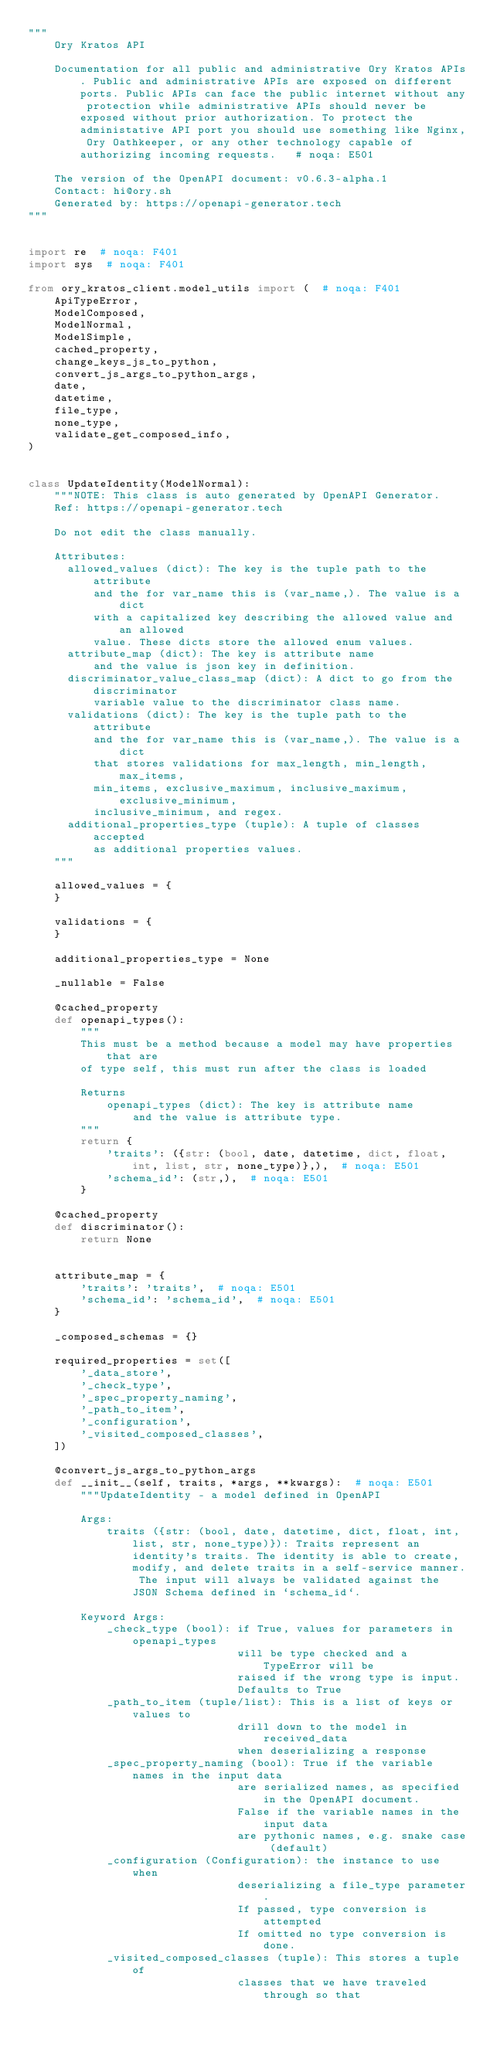Convert code to text. <code><loc_0><loc_0><loc_500><loc_500><_Python_>"""
    Ory Kratos API

    Documentation for all public and administrative Ory Kratos APIs. Public and administrative APIs are exposed on different ports. Public APIs can face the public internet without any protection while administrative APIs should never be exposed without prior authorization. To protect the administative API port you should use something like Nginx, Ory Oathkeeper, or any other technology capable of authorizing incoming requests.   # noqa: E501

    The version of the OpenAPI document: v0.6.3-alpha.1
    Contact: hi@ory.sh
    Generated by: https://openapi-generator.tech
"""


import re  # noqa: F401
import sys  # noqa: F401

from ory_kratos_client.model_utils import (  # noqa: F401
    ApiTypeError,
    ModelComposed,
    ModelNormal,
    ModelSimple,
    cached_property,
    change_keys_js_to_python,
    convert_js_args_to_python_args,
    date,
    datetime,
    file_type,
    none_type,
    validate_get_composed_info,
)


class UpdateIdentity(ModelNormal):
    """NOTE: This class is auto generated by OpenAPI Generator.
    Ref: https://openapi-generator.tech

    Do not edit the class manually.

    Attributes:
      allowed_values (dict): The key is the tuple path to the attribute
          and the for var_name this is (var_name,). The value is a dict
          with a capitalized key describing the allowed value and an allowed
          value. These dicts store the allowed enum values.
      attribute_map (dict): The key is attribute name
          and the value is json key in definition.
      discriminator_value_class_map (dict): A dict to go from the discriminator
          variable value to the discriminator class name.
      validations (dict): The key is the tuple path to the attribute
          and the for var_name this is (var_name,). The value is a dict
          that stores validations for max_length, min_length, max_items,
          min_items, exclusive_maximum, inclusive_maximum, exclusive_minimum,
          inclusive_minimum, and regex.
      additional_properties_type (tuple): A tuple of classes accepted
          as additional properties values.
    """

    allowed_values = {
    }

    validations = {
    }

    additional_properties_type = None

    _nullable = False

    @cached_property
    def openapi_types():
        """
        This must be a method because a model may have properties that are
        of type self, this must run after the class is loaded

        Returns
            openapi_types (dict): The key is attribute name
                and the value is attribute type.
        """
        return {
            'traits': ({str: (bool, date, datetime, dict, float, int, list, str, none_type)},),  # noqa: E501
            'schema_id': (str,),  # noqa: E501
        }

    @cached_property
    def discriminator():
        return None


    attribute_map = {
        'traits': 'traits',  # noqa: E501
        'schema_id': 'schema_id',  # noqa: E501
    }

    _composed_schemas = {}

    required_properties = set([
        '_data_store',
        '_check_type',
        '_spec_property_naming',
        '_path_to_item',
        '_configuration',
        '_visited_composed_classes',
    ])

    @convert_js_args_to_python_args
    def __init__(self, traits, *args, **kwargs):  # noqa: E501
        """UpdateIdentity - a model defined in OpenAPI

        Args:
            traits ({str: (bool, date, datetime, dict, float, int, list, str, none_type)}): Traits represent an identity's traits. The identity is able to create, modify, and delete traits in a self-service manner. The input will always be validated against the JSON Schema defined in `schema_id`.

        Keyword Args:
            _check_type (bool): if True, values for parameters in openapi_types
                                will be type checked and a TypeError will be
                                raised if the wrong type is input.
                                Defaults to True
            _path_to_item (tuple/list): This is a list of keys or values to
                                drill down to the model in received_data
                                when deserializing a response
            _spec_property_naming (bool): True if the variable names in the input data
                                are serialized names, as specified in the OpenAPI document.
                                False if the variable names in the input data
                                are pythonic names, e.g. snake case (default)
            _configuration (Configuration): the instance to use when
                                deserializing a file_type parameter.
                                If passed, type conversion is attempted
                                If omitted no type conversion is done.
            _visited_composed_classes (tuple): This stores a tuple of
                                classes that we have traveled through so that</code> 